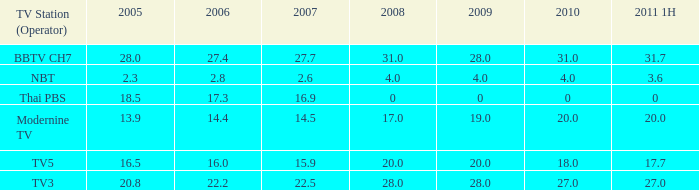What is the highest 2011 1H value for a 2005 over 28? None. 